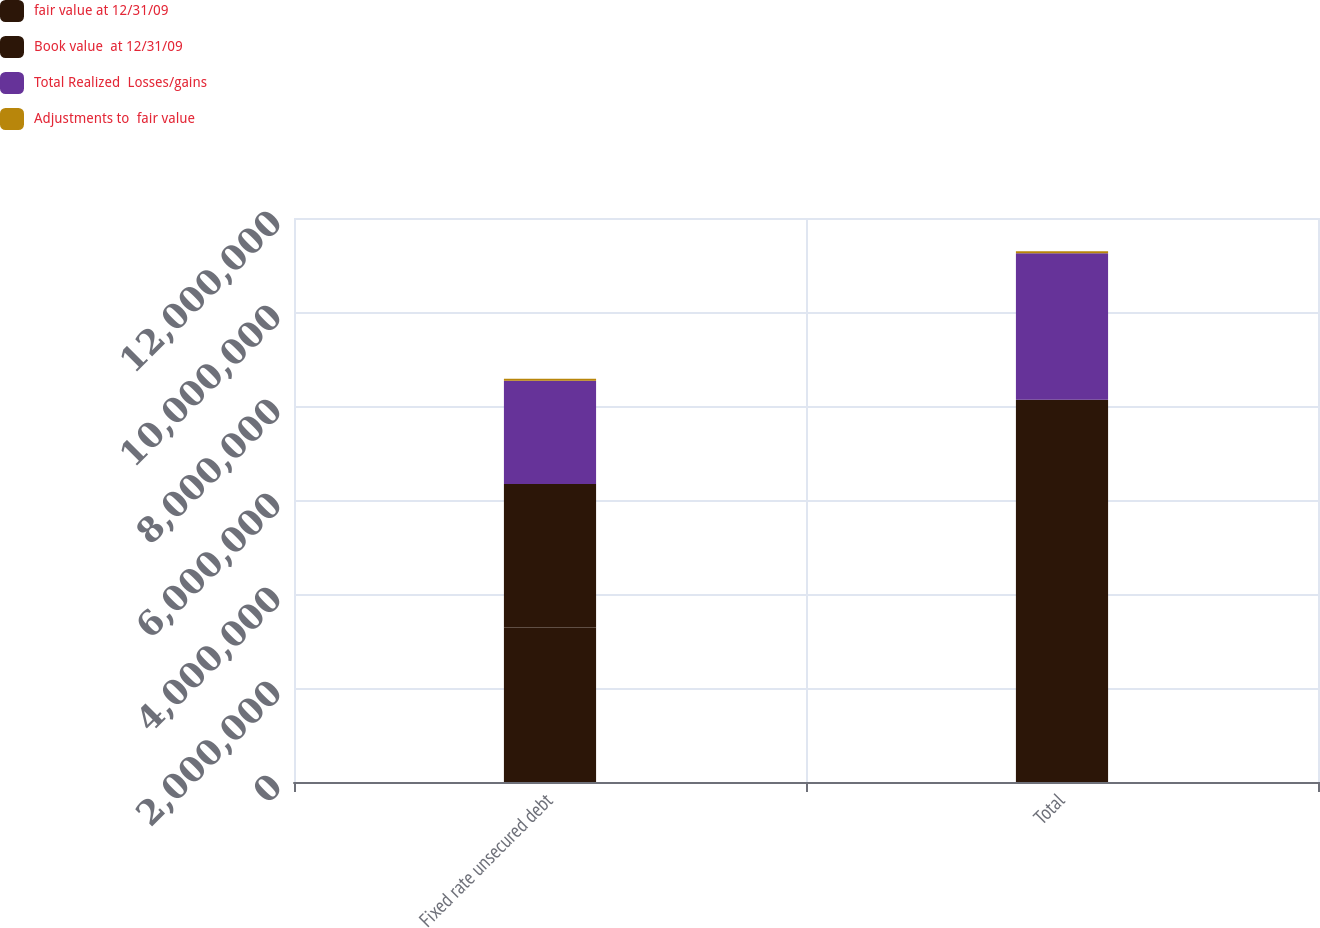Convert chart. <chart><loc_0><loc_0><loc_500><loc_500><stacked_bar_chart><ecel><fcel>Fixed rate unsecured debt<fcel>Total<nl><fcel>fair value at 12/31/09<fcel>3.28598e+06<fcel>4.27699e+06<nl><fcel>Book value  at 12/31/09<fcel>3.05246e+06<fcel>3.85403e+06<nl><fcel>Total Realized  Losses/gains<fcel>2.19669e+06<fcel>3.12011e+06<nl><fcel>Adjustments to  fair value<fcel>42028<fcel>42028<nl></chart> 